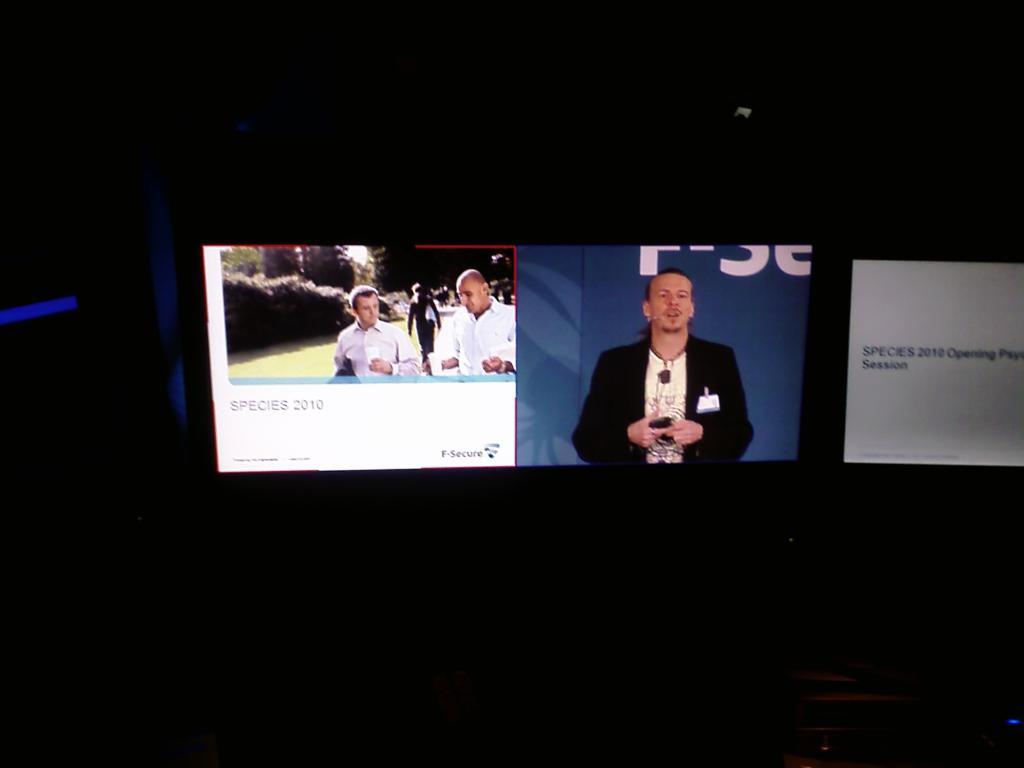<image>
Write a terse but informative summary of the picture. Three screens sit side by side, the left showing some men with Species 2010 below the image. 